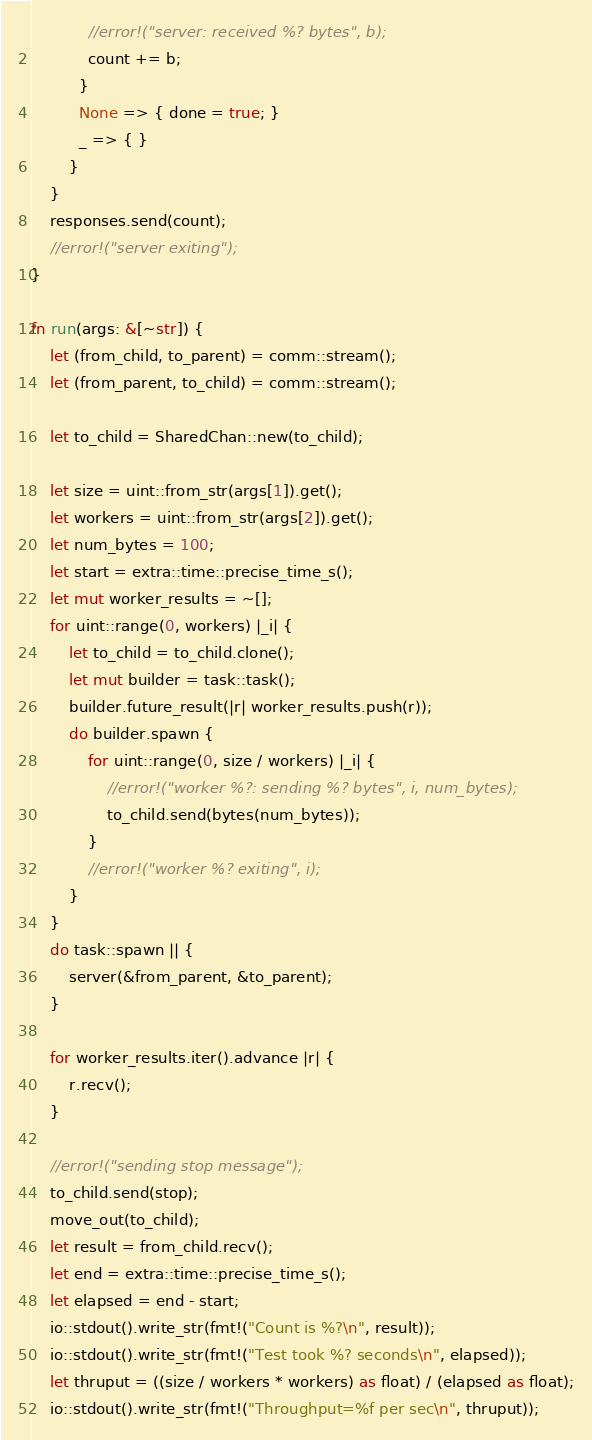Convert code to text. <code><loc_0><loc_0><loc_500><loc_500><_Rust_>            //error!("server: received %? bytes", b);
            count += b;
          }
          None => { done = true; }
          _ => { }
        }
    }
    responses.send(count);
    //error!("server exiting");
}

fn run(args: &[~str]) {
    let (from_child, to_parent) = comm::stream();
    let (from_parent, to_child) = comm::stream();

    let to_child = SharedChan::new(to_child);

    let size = uint::from_str(args[1]).get();
    let workers = uint::from_str(args[2]).get();
    let num_bytes = 100;
    let start = extra::time::precise_time_s();
    let mut worker_results = ~[];
    for uint::range(0, workers) |_i| {
        let to_child = to_child.clone();
        let mut builder = task::task();
        builder.future_result(|r| worker_results.push(r));
        do builder.spawn {
            for uint::range(0, size / workers) |_i| {
                //error!("worker %?: sending %? bytes", i, num_bytes);
                to_child.send(bytes(num_bytes));
            }
            //error!("worker %? exiting", i);
        }
    }
    do task::spawn || {
        server(&from_parent, &to_parent);
    }

    for worker_results.iter().advance |r| {
        r.recv();
    }

    //error!("sending stop message");
    to_child.send(stop);
    move_out(to_child);
    let result = from_child.recv();
    let end = extra::time::precise_time_s();
    let elapsed = end - start;
    io::stdout().write_str(fmt!("Count is %?\n", result));
    io::stdout().write_str(fmt!("Test took %? seconds\n", elapsed));
    let thruput = ((size / workers * workers) as float) / (elapsed as float);
    io::stdout().write_str(fmt!("Throughput=%f per sec\n", thruput));</code> 